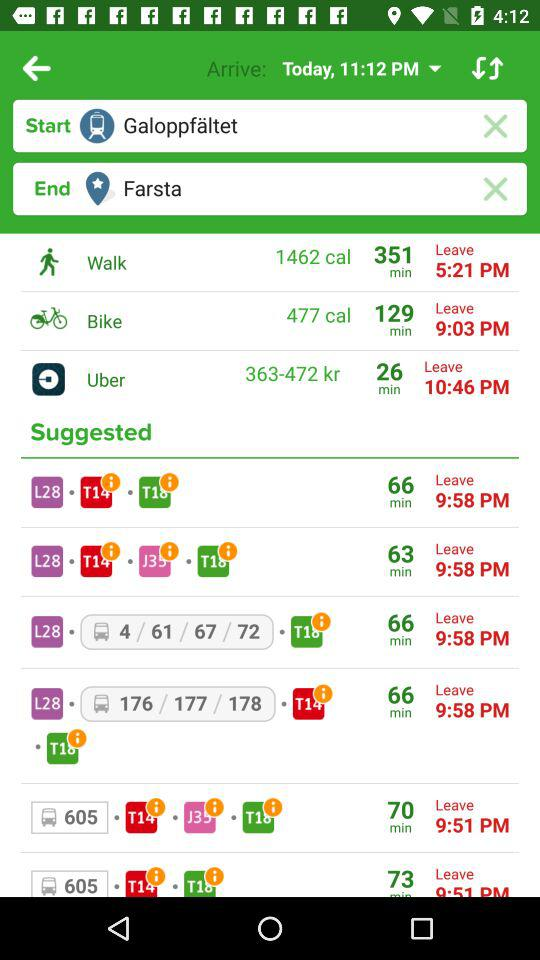What is today's arrival time? Today's arrival time is 11:12 PM. 